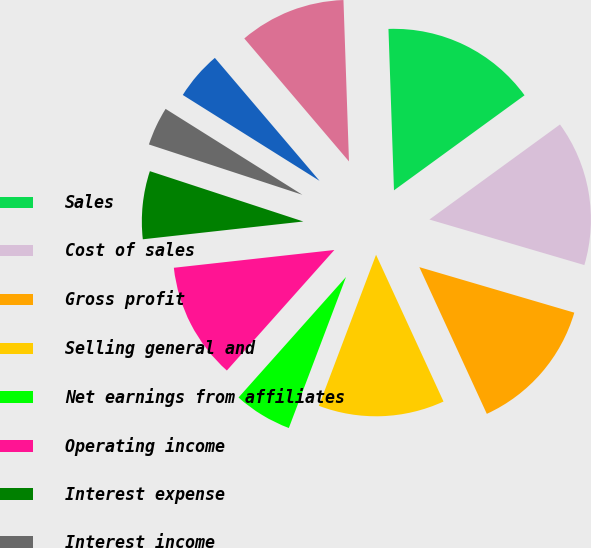<chart> <loc_0><loc_0><loc_500><loc_500><pie_chart><fcel>Sales<fcel>Cost of sales<fcel>Gross profit<fcel>Selling general and<fcel>Net earnings from affiliates<fcel>Operating income<fcel>Interest expense<fcel>Interest income<fcel>Other (expense) income net<fcel>Earnings before income taxes<nl><fcel>15.53%<fcel>14.56%<fcel>13.59%<fcel>12.62%<fcel>5.83%<fcel>11.65%<fcel>6.8%<fcel>3.88%<fcel>4.85%<fcel>10.68%<nl></chart> 